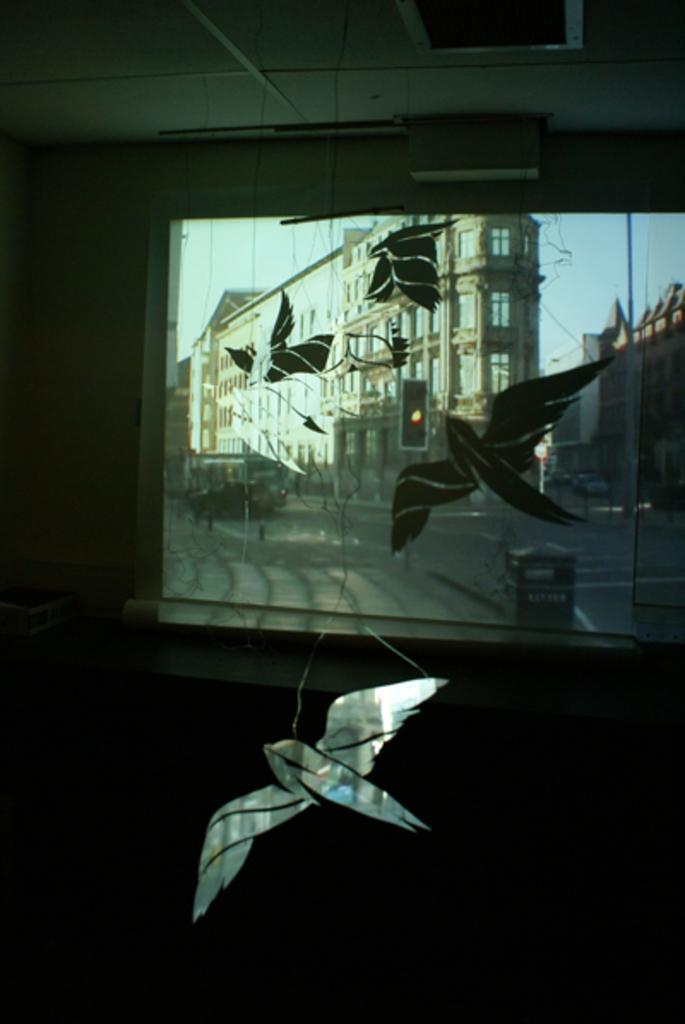What device is the main subject of the image? There is a projector in the image. What is the projector doing in the image? The projector is projecting onto a board. What images can be seen on the board? There are birds and a building depicted on the board. What part of the room is visible at the top of the image? The ceiling is visible at the top of the image. What type of fruit is hanging from the projector in the image? There is no fruit hanging from the projector in the image. What kind of plant can be seen growing on the board? There are no plants depicted on the board in the image. 